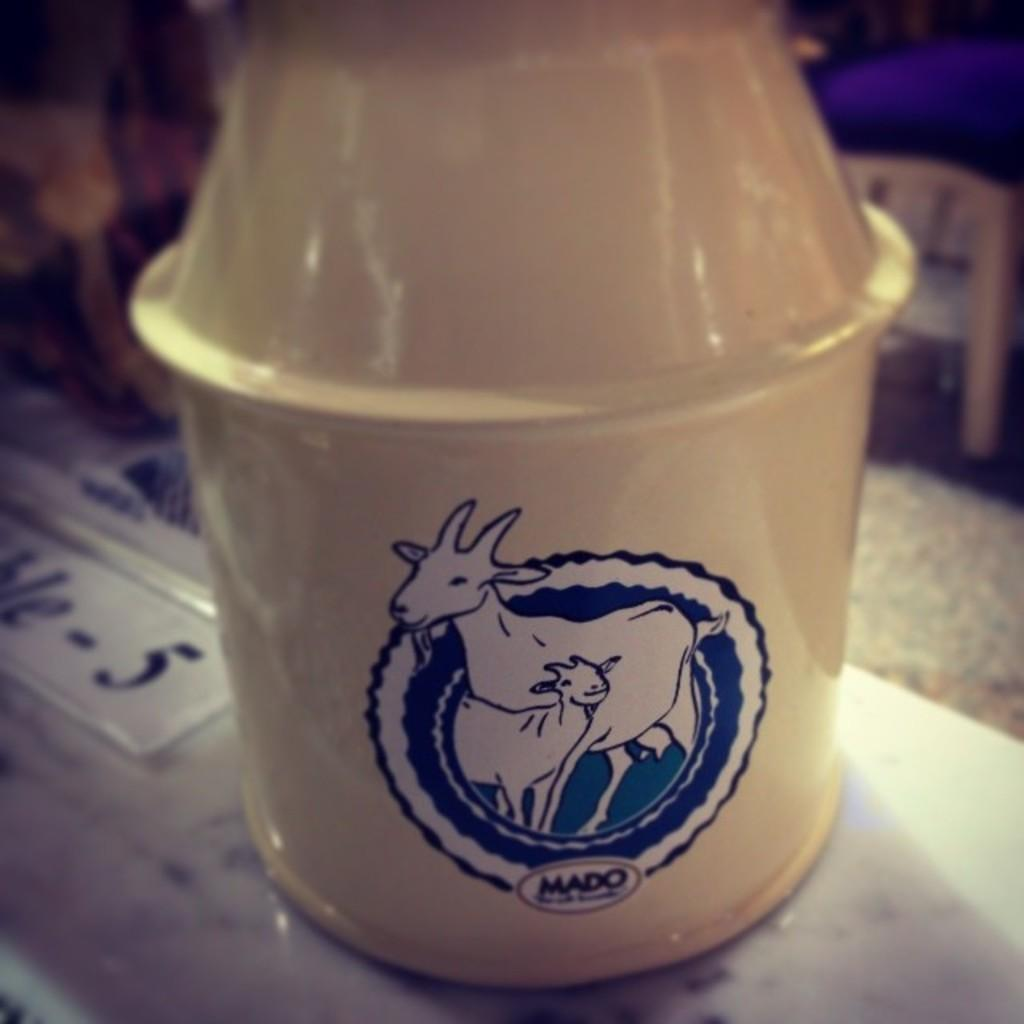What can be seen in the image? There is an object in the image. Can you describe the placement of the object? The object is placed on a surface. What type of gold is used to create the example in the image? There is no gold or example present in the image. The image only contains an object placed on a surface. 